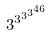Convert formula to latex. <formula><loc_0><loc_0><loc_500><loc_500>3 ^ { 3 ^ { 3 ^ { 3 ^ { 4 6 } } } }</formula> 